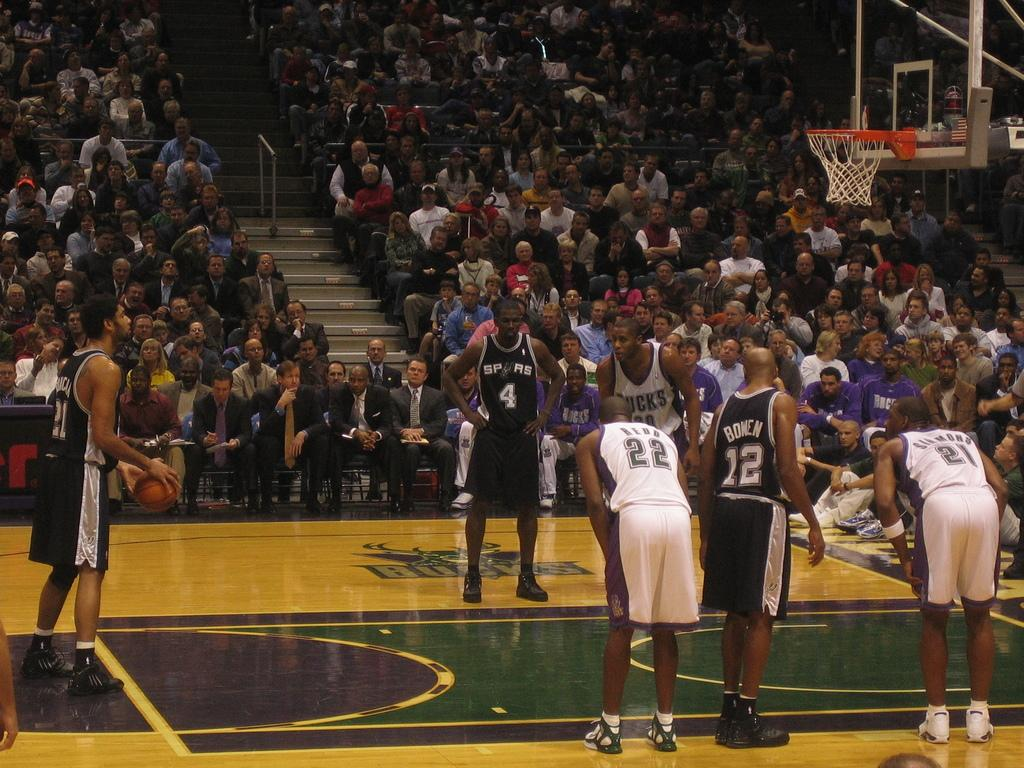What activity are the people in the center of the image engaged in? There are basketball players in the center of the image. Can you describe the people in the background of the image? There is a group of people in the background of the image as an audience. How many jellyfish can be seen swimming at the edge of the image? There are no jellyfish present in the image. What is the topic of the argument taking place in the image? There is no argument present in the image. 